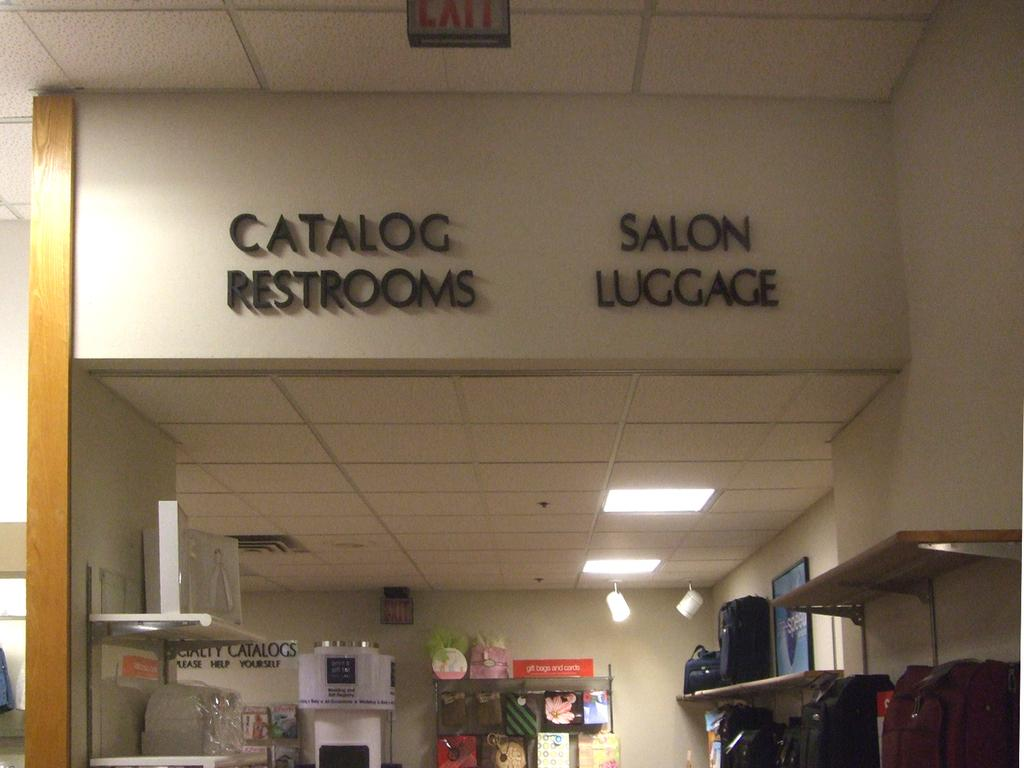<image>
Share a concise interpretation of the image provided. One can see two signs shown above, including one for catalog restrooms. 